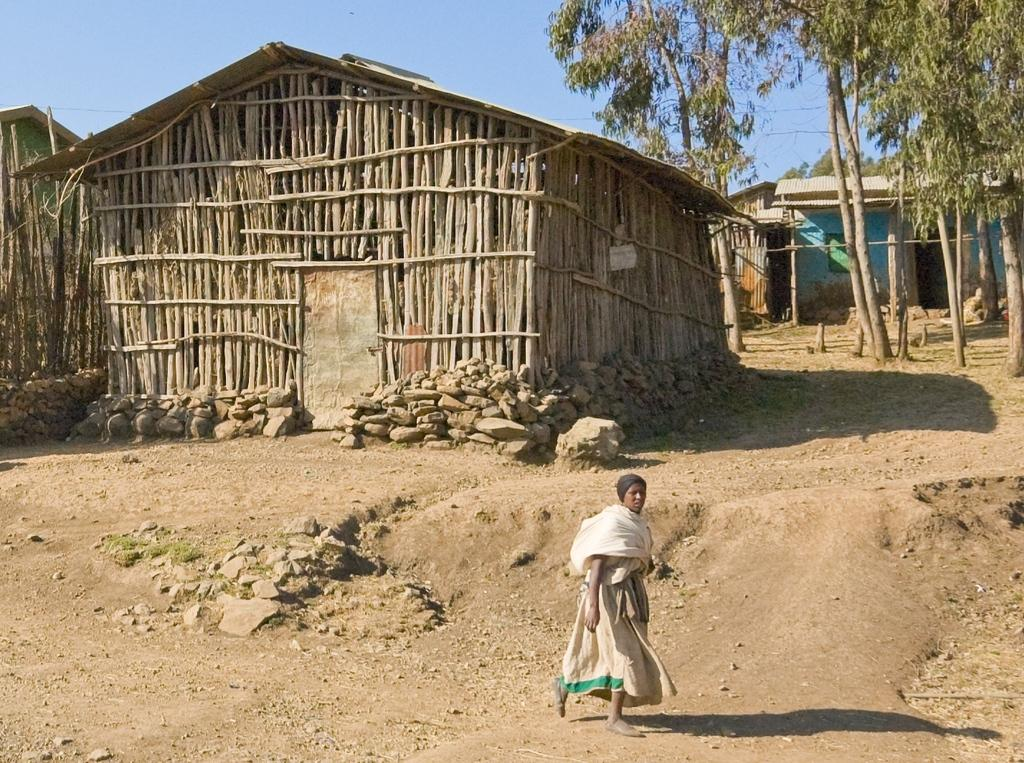What type of structure is in the image? There is a hut in the image. What can be seen behind the hut? There are trees behind the hut. What is located behind the trees? There is a house behind the trees. What is the woman in the image doing? There is a woman walking on the soil surface in front of the hut. How much money is the woman carrying in the image? There is no indication of money or any financial transaction in the image. 